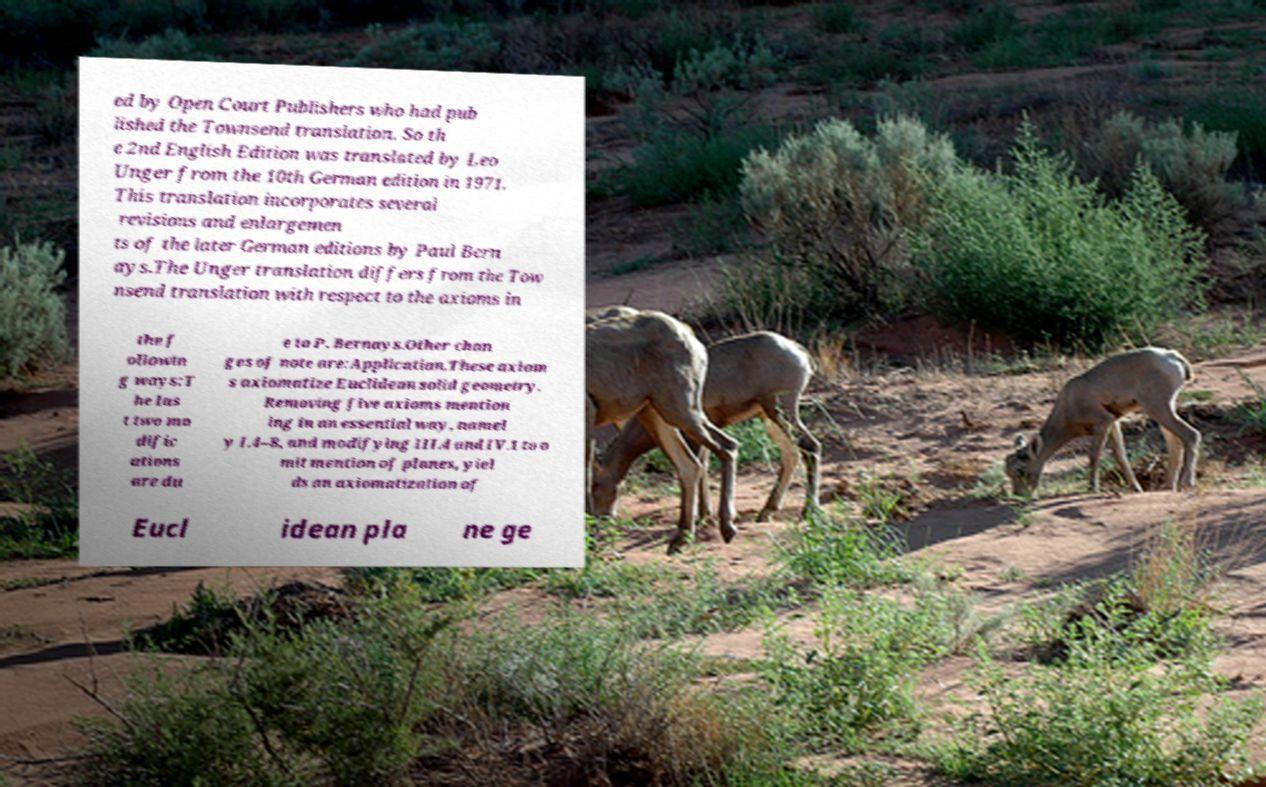Please read and relay the text visible in this image. What does it say? ed by Open Court Publishers who had pub lished the Townsend translation. So th e 2nd English Edition was translated by Leo Unger from the 10th German edition in 1971. This translation incorporates several revisions and enlargemen ts of the later German editions by Paul Bern ays.The Unger translation differs from the Tow nsend translation with respect to the axioms in the f ollowin g ways:T he las t two mo dific ations are du e to P. Bernays.Other chan ges of note are:Application.These axiom s axiomatize Euclidean solid geometry. Removing five axioms mention ing in an essential way, namel y I.4–8, and modifying III.4 and IV.1 to o mit mention of planes, yiel ds an axiomatization of Eucl idean pla ne ge 